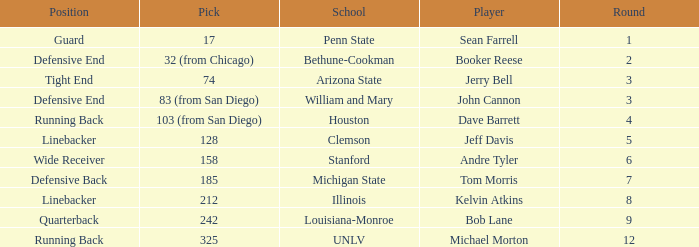During which round did tom morris get picked? 1.0. 